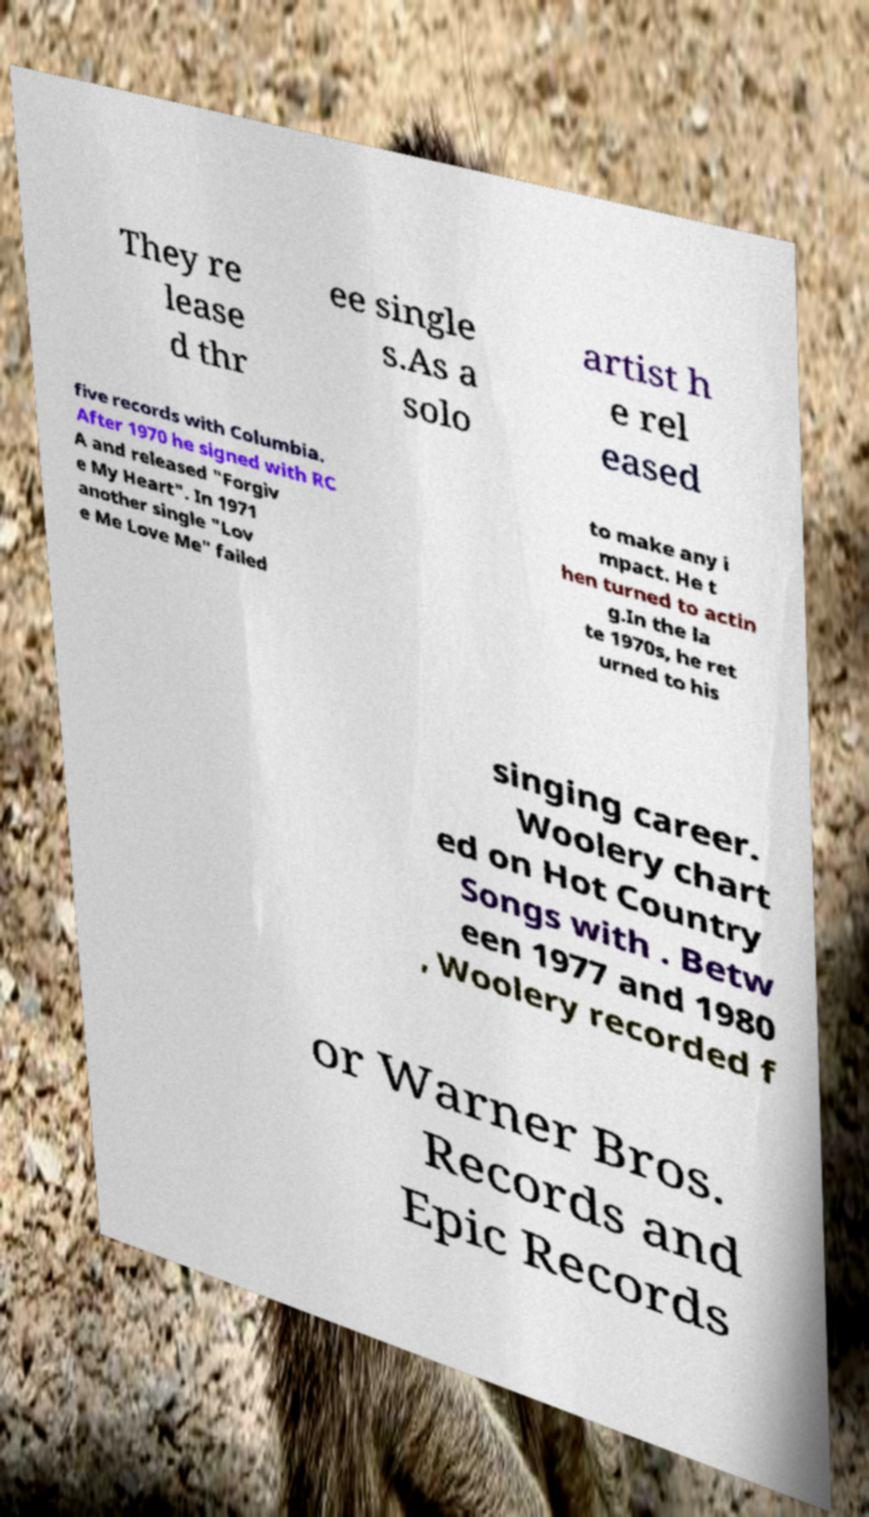For documentation purposes, I need the text within this image transcribed. Could you provide that? They re lease d thr ee single s.As a solo artist h e rel eased five records with Columbia. After 1970 he signed with RC A and released "Forgiv e My Heart". In 1971 another single "Lov e Me Love Me" failed to make any i mpact. He t hen turned to actin g.In the la te 1970s, he ret urned to his singing career. Woolery chart ed on Hot Country Songs with . Betw een 1977 and 1980 , Woolery recorded f or Warner Bros. Records and Epic Records 